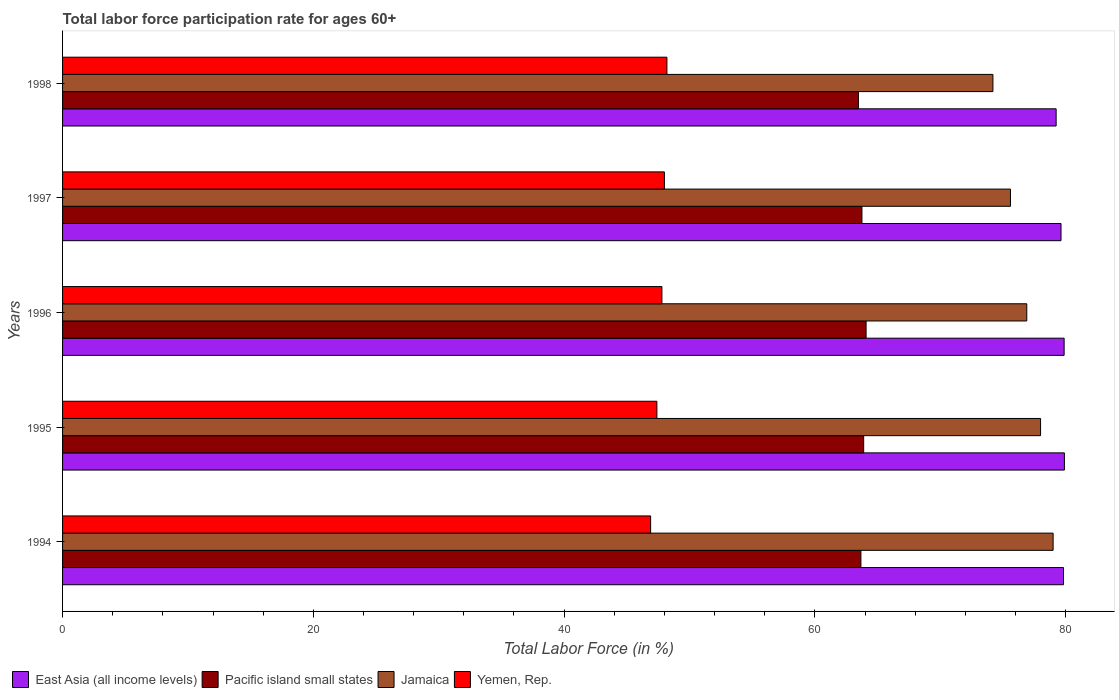How many different coloured bars are there?
Make the answer very short. 4. Are the number of bars per tick equal to the number of legend labels?
Give a very brief answer. Yes. How many bars are there on the 1st tick from the bottom?
Your answer should be compact. 4. What is the label of the 3rd group of bars from the top?
Your answer should be very brief. 1996. In how many cases, is the number of bars for a given year not equal to the number of legend labels?
Provide a short and direct response. 0. What is the labor force participation rate in Jamaica in 1997?
Offer a very short reply. 75.6. Across all years, what is the maximum labor force participation rate in East Asia (all income levels)?
Give a very brief answer. 79.9. Across all years, what is the minimum labor force participation rate in East Asia (all income levels)?
Ensure brevity in your answer.  79.24. What is the total labor force participation rate in East Asia (all income levels) in the graph?
Your response must be concise. 398.48. What is the difference between the labor force participation rate in Jamaica in 1995 and that in 1996?
Give a very brief answer. 1.1. What is the difference between the labor force participation rate in Jamaica in 1998 and the labor force participation rate in East Asia (all income levels) in 1997?
Offer a very short reply. -5.43. What is the average labor force participation rate in Jamaica per year?
Offer a very short reply. 76.74. In the year 1994, what is the difference between the labor force participation rate in East Asia (all income levels) and labor force participation rate in Pacific island small states?
Offer a very short reply. 16.16. In how many years, is the labor force participation rate in Jamaica greater than 64 %?
Your answer should be compact. 5. What is the ratio of the labor force participation rate in Pacific island small states in 1994 to that in 1997?
Give a very brief answer. 1. Is the difference between the labor force participation rate in East Asia (all income levels) in 1994 and 1996 greater than the difference between the labor force participation rate in Pacific island small states in 1994 and 1996?
Offer a very short reply. Yes. What is the difference between the highest and the second highest labor force participation rate in Yemen, Rep.?
Your answer should be compact. 0.2. What is the difference between the highest and the lowest labor force participation rate in Jamaica?
Ensure brevity in your answer.  4.8. Is it the case that in every year, the sum of the labor force participation rate in Yemen, Rep. and labor force participation rate in East Asia (all income levels) is greater than the sum of labor force participation rate in Jamaica and labor force participation rate in Pacific island small states?
Keep it short and to the point. No. What does the 3rd bar from the top in 1996 represents?
Provide a short and direct response. Pacific island small states. What does the 1st bar from the bottom in 1998 represents?
Your answer should be compact. East Asia (all income levels). How many years are there in the graph?
Your answer should be very brief. 5. What is the difference between two consecutive major ticks on the X-axis?
Give a very brief answer. 20. Are the values on the major ticks of X-axis written in scientific E-notation?
Keep it short and to the point. No. Does the graph contain grids?
Your response must be concise. No. Where does the legend appear in the graph?
Your answer should be very brief. Bottom left. What is the title of the graph?
Your answer should be very brief. Total labor force participation rate for ages 60+. Does "Caribbean small states" appear as one of the legend labels in the graph?
Your response must be concise. No. What is the label or title of the X-axis?
Offer a very short reply. Total Labor Force (in %). What is the label or title of the Y-axis?
Keep it short and to the point. Years. What is the Total Labor Force (in %) in East Asia (all income levels) in 1994?
Your response must be concise. 79.83. What is the Total Labor Force (in %) in Pacific island small states in 1994?
Ensure brevity in your answer.  63.67. What is the Total Labor Force (in %) of Jamaica in 1994?
Offer a very short reply. 79. What is the Total Labor Force (in %) in Yemen, Rep. in 1994?
Keep it short and to the point. 46.9. What is the Total Labor Force (in %) in East Asia (all income levels) in 1995?
Keep it short and to the point. 79.9. What is the Total Labor Force (in %) of Pacific island small states in 1995?
Ensure brevity in your answer.  63.89. What is the Total Labor Force (in %) in Yemen, Rep. in 1995?
Provide a succinct answer. 47.4. What is the Total Labor Force (in %) of East Asia (all income levels) in 1996?
Offer a terse response. 79.88. What is the Total Labor Force (in %) of Pacific island small states in 1996?
Make the answer very short. 64.08. What is the Total Labor Force (in %) in Jamaica in 1996?
Your answer should be compact. 76.9. What is the Total Labor Force (in %) in Yemen, Rep. in 1996?
Your response must be concise. 47.8. What is the Total Labor Force (in %) of East Asia (all income levels) in 1997?
Make the answer very short. 79.63. What is the Total Labor Force (in %) in Pacific island small states in 1997?
Offer a terse response. 63.75. What is the Total Labor Force (in %) in Jamaica in 1997?
Make the answer very short. 75.6. What is the Total Labor Force (in %) of Yemen, Rep. in 1997?
Provide a succinct answer. 48. What is the Total Labor Force (in %) of East Asia (all income levels) in 1998?
Give a very brief answer. 79.24. What is the Total Labor Force (in %) in Pacific island small states in 1998?
Provide a succinct answer. 63.47. What is the Total Labor Force (in %) of Jamaica in 1998?
Your answer should be compact. 74.2. What is the Total Labor Force (in %) of Yemen, Rep. in 1998?
Make the answer very short. 48.2. Across all years, what is the maximum Total Labor Force (in %) in East Asia (all income levels)?
Keep it short and to the point. 79.9. Across all years, what is the maximum Total Labor Force (in %) in Pacific island small states?
Provide a succinct answer. 64.08. Across all years, what is the maximum Total Labor Force (in %) of Jamaica?
Your answer should be very brief. 79. Across all years, what is the maximum Total Labor Force (in %) in Yemen, Rep.?
Keep it short and to the point. 48.2. Across all years, what is the minimum Total Labor Force (in %) in East Asia (all income levels)?
Your answer should be compact. 79.24. Across all years, what is the minimum Total Labor Force (in %) of Pacific island small states?
Provide a short and direct response. 63.47. Across all years, what is the minimum Total Labor Force (in %) in Jamaica?
Your answer should be very brief. 74.2. Across all years, what is the minimum Total Labor Force (in %) of Yemen, Rep.?
Offer a terse response. 46.9. What is the total Total Labor Force (in %) in East Asia (all income levels) in the graph?
Keep it short and to the point. 398.48. What is the total Total Labor Force (in %) of Pacific island small states in the graph?
Your response must be concise. 318.87. What is the total Total Labor Force (in %) in Jamaica in the graph?
Your answer should be compact. 383.7. What is the total Total Labor Force (in %) in Yemen, Rep. in the graph?
Your answer should be compact. 238.3. What is the difference between the Total Labor Force (in %) of East Asia (all income levels) in 1994 and that in 1995?
Ensure brevity in your answer.  -0.07. What is the difference between the Total Labor Force (in %) in Pacific island small states in 1994 and that in 1995?
Your answer should be very brief. -0.22. What is the difference between the Total Labor Force (in %) of Jamaica in 1994 and that in 1995?
Keep it short and to the point. 1. What is the difference between the Total Labor Force (in %) of East Asia (all income levels) in 1994 and that in 1996?
Ensure brevity in your answer.  -0.05. What is the difference between the Total Labor Force (in %) in Pacific island small states in 1994 and that in 1996?
Your answer should be compact. -0.41. What is the difference between the Total Labor Force (in %) in Jamaica in 1994 and that in 1996?
Your response must be concise. 2.1. What is the difference between the Total Labor Force (in %) of Yemen, Rep. in 1994 and that in 1996?
Your answer should be very brief. -0.9. What is the difference between the Total Labor Force (in %) of East Asia (all income levels) in 1994 and that in 1997?
Give a very brief answer. 0.2. What is the difference between the Total Labor Force (in %) in Pacific island small states in 1994 and that in 1997?
Offer a very short reply. -0.08. What is the difference between the Total Labor Force (in %) in East Asia (all income levels) in 1994 and that in 1998?
Keep it short and to the point. 0.59. What is the difference between the Total Labor Force (in %) of Pacific island small states in 1994 and that in 1998?
Make the answer very short. 0.2. What is the difference between the Total Labor Force (in %) of Jamaica in 1994 and that in 1998?
Your answer should be compact. 4.8. What is the difference between the Total Labor Force (in %) of East Asia (all income levels) in 1995 and that in 1996?
Your response must be concise. 0.02. What is the difference between the Total Labor Force (in %) in Pacific island small states in 1995 and that in 1996?
Your response must be concise. -0.19. What is the difference between the Total Labor Force (in %) in Jamaica in 1995 and that in 1996?
Give a very brief answer. 1.1. What is the difference between the Total Labor Force (in %) of Yemen, Rep. in 1995 and that in 1996?
Your answer should be very brief. -0.4. What is the difference between the Total Labor Force (in %) in East Asia (all income levels) in 1995 and that in 1997?
Your answer should be very brief. 0.27. What is the difference between the Total Labor Force (in %) of Pacific island small states in 1995 and that in 1997?
Give a very brief answer. 0.14. What is the difference between the Total Labor Force (in %) in Jamaica in 1995 and that in 1997?
Your answer should be very brief. 2.4. What is the difference between the Total Labor Force (in %) in Yemen, Rep. in 1995 and that in 1997?
Make the answer very short. -0.6. What is the difference between the Total Labor Force (in %) of East Asia (all income levels) in 1995 and that in 1998?
Your response must be concise. 0.66. What is the difference between the Total Labor Force (in %) of Pacific island small states in 1995 and that in 1998?
Offer a very short reply. 0.42. What is the difference between the Total Labor Force (in %) of Jamaica in 1995 and that in 1998?
Keep it short and to the point. 3.8. What is the difference between the Total Labor Force (in %) of East Asia (all income levels) in 1996 and that in 1997?
Keep it short and to the point. 0.25. What is the difference between the Total Labor Force (in %) in Pacific island small states in 1996 and that in 1997?
Give a very brief answer. 0.33. What is the difference between the Total Labor Force (in %) of Jamaica in 1996 and that in 1997?
Your answer should be compact. 1.3. What is the difference between the Total Labor Force (in %) of East Asia (all income levels) in 1996 and that in 1998?
Your answer should be very brief. 0.64. What is the difference between the Total Labor Force (in %) of Pacific island small states in 1996 and that in 1998?
Your answer should be very brief. 0.61. What is the difference between the Total Labor Force (in %) in East Asia (all income levels) in 1997 and that in 1998?
Give a very brief answer. 0.39. What is the difference between the Total Labor Force (in %) of Pacific island small states in 1997 and that in 1998?
Your answer should be compact. 0.28. What is the difference between the Total Labor Force (in %) of East Asia (all income levels) in 1994 and the Total Labor Force (in %) of Pacific island small states in 1995?
Offer a very short reply. 15.94. What is the difference between the Total Labor Force (in %) of East Asia (all income levels) in 1994 and the Total Labor Force (in %) of Jamaica in 1995?
Provide a succinct answer. 1.83. What is the difference between the Total Labor Force (in %) of East Asia (all income levels) in 1994 and the Total Labor Force (in %) of Yemen, Rep. in 1995?
Your answer should be very brief. 32.43. What is the difference between the Total Labor Force (in %) in Pacific island small states in 1994 and the Total Labor Force (in %) in Jamaica in 1995?
Ensure brevity in your answer.  -14.33. What is the difference between the Total Labor Force (in %) of Pacific island small states in 1994 and the Total Labor Force (in %) of Yemen, Rep. in 1995?
Your response must be concise. 16.27. What is the difference between the Total Labor Force (in %) of Jamaica in 1994 and the Total Labor Force (in %) of Yemen, Rep. in 1995?
Give a very brief answer. 31.6. What is the difference between the Total Labor Force (in %) of East Asia (all income levels) in 1994 and the Total Labor Force (in %) of Pacific island small states in 1996?
Your answer should be compact. 15.74. What is the difference between the Total Labor Force (in %) in East Asia (all income levels) in 1994 and the Total Labor Force (in %) in Jamaica in 1996?
Make the answer very short. 2.93. What is the difference between the Total Labor Force (in %) in East Asia (all income levels) in 1994 and the Total Labor Force (in %) in Yemen, Rep. in 1996?
Offer a very short reply. 32.03. What is the difference between the Total Labor Force (in %) of Pacific island small states in 1994 and the Total Labor Force (in %) of Jamaica in 1996?
Provide a succinct answer. -13.23. What is the difference between the Total Labor Force (in %) in Pacific island small states in 1994 and the Total Labor Force (in %) in Yemen, Rep. in 1996?
Provide a short and direct response. 15.87. What is the difference between the Total Labor Force (in %) of Jamaica in 1994 and the Total Labor Force (in %) of Yemen, Rep. in 1996?
Keep it short and to the point. 31.2. What is the difference between the Total Labor Force (in %) of East Asia (all income levels) in 1994 and the Total Labor Force (in %) of Pacific island small states in 1997?
Your answer should be very brief. 16.07. What is the difference between the Total Labor Force (in %) of East Asia (all income levels) in 1994 and the Total Labor Force (in %) of Jamaica in 1997?
Give a very brief answer. 4.23. What is the difference between the Total Labor Force (in %) of East Asia (all income levels) in 1994 and the Total Labor Force (in %) of Yemen, Rep. in 1997?
Keep it short and to the point. 31.83. What is the difference between the Total Labor Force (in %) in Pacific island small states in 1994 and the Total Labor Force (in %) in Jamaica in 1997?
Make the answer very short. -11.93. What is the difference between the Total Labor Force (in %) of Pacific island small states in 1994 and the Total Labor Force (in %) of Yemen, Rep. in 1997?
Make the answer very short. 15.67. What is the difference between the Total Labor Force (in %) of East Asia (all income levels) in 1994 and the Total Labor Force (in %) of Pacific island small states in 1998?
Provide a short and direct response. 16.36. What is the difference between the Total Labor Force (in %) of East Asia (all income levels) in 1994 and the Total Labor Force (in %) of Jamaica in 1998?
Your response must be concise. 5.63. What is the difference between the Total Labor Force (in %) of East Asia (all income levels) in 1994 and the Total Labor Force (in %) of Yemen, Rep. in 1998?
Ensure brevity in your answer.  31.63. What is the difference between the Total Labor Force (in %) in Pacific island small states in 1994 and the Total Labor Force (in %) in Jamaica in 1998?
Offer a very short reply. -10.53. What is the difference between the Total Labor Force (in %) of Pacific island small states in 1994 and the Total Labor Force (in %) of Yemen, Rep. in 1998?
Your answer should be very brief. 15.47. What is the difference between the Total Labor Force (in %) in Jamaica in 1994 and the Total Labor Force (in %) in Yemen, Rep. in 1998?
Provide a succinct answer. 30.8. What is the difference between the Total Labor Force (in %) of East Asia (all income levels) in 1995 and the Total Labor Force (in %) of Pacific island small states in 1996?
Provide a short and direct response. 15.82. What is the difference between the Total Labor Force (in %) of East Asia (all income levels) in 1995 and the Total Labor Force (in %) of Jamaica in 1996?
Provide a succinct answer. 3. What is the difference between the Total Labor Force (in %) in East Asia (all income levels) in 1995 and the Total Labor Force (in %) in Yemen, Rep. in 1996?
Provide a succinct answer. 32.1. What is the difference between the Total Labor Force (in %) of Pacific island small states in 1995 and the Total Labor Force (in %) of Jamaica in 1996?
Your response must be concise. -13.01. What is the difference between the Total Labor Force (in %) in Pacific island small states in 1995 and the Total Labor Force (in %) in Yemen, Rep. in 1996?
Your response must be concise. 16.09. What is the difference between the Total Labor Force (in %) in Jamaica in 1995 and the Total Labor Force (in %) in Yemen, Rep. in 1996?
Your answer should be compact. 30.2. What is the difference between the Total Labor Force (in %) of East Asia (all income levels) in 1995 and the Total Labor Force (in %) of Pacific island small states in 1997?
Give a very brief answer. 16.15. What is the difference between the Total Labor Force (in %) of East Asia (all income levels) in 1995 and the Total Labor Force (in %) of Jamaica in 1997?
Make the answer very short. 4.3. What is the difference between the Total Labor Force (in %) in East Asia (all income levels) in 1995 and the Total Labor Force (in %) in Yemen, Rep. in 1997?
Your answer should be compact. 31.9. What is the difference between the Total Labor Force (in %) of Pacific island small states in 1995 and the Total Labor Force (in %) of Jamaica in 1997?
Provide a succinct answer. -11.71. What is the difference between the Total Labor Force (in %) of Pacific island small states in 1995 and the Total Labor Force (in %) of Yemen, Rep. in 1997?
Your answer should be compact. 15.89. What is the difference between the Total Labor Force (in %) in Jamaica in 1995 and the Total Labor Force (in %) in Yemen, Rep. in 1997?
Give a very brief answer. 30. What is the difference between the Total Labor Force (in %) of East Asia (all income levels) in 1995 and the Total Labor Force (in %) of Pacific island small states in 1998?
Offer a very short reply. 16.43. What is the difference between the Total Labor Force (in %) of East Asia (all income levels) in 1995 and the Total Labor Force (in %) of Jamaica in 1998?
Your answer should be compact. 5.7. What is the difference between the Total Labor Force (in %) of East Asia (all income levels) in 1995 and the Total Labor Force (in %) of Yemen, Rep. in 1998?
Provide a short and direct response. 31.7. What is the difference between the Total Labor Force (in %) in Pacific island small states in 1995 and the Total Labor Force (in %) in Jamaica in 1998?
Your response must be concise. -10.31. What is the difference between the Total Labor Force (in %) in Pacific island small states in 1995 and the Total Labor Force (in %) in Yemen, Rep. in 1998?
Ensure brevity in your answer.  15.69. What is the difference between the Total Labor Force (in %) in Jamaica in 1995 and the Total Labor Force (in %) in Yemen, Rep. in 1998?
Your answer should be compact. 29.8. What is the difference between the Total Labor Force (in %) in East Asia (all income levels) in 1996 and the Total Labor Force (in %) in Pacific island small states in 1997?
Offer a terse response. 16.13. What is the difference between the Total Labor Force (in %) of East Asia (all income levels) in 1996 and the Total Labor Force (in %) of Jamaica in 1997?
Give a very brief answer. 4.28. What is the difference between the Total Labor Force (in %) in East Asia (all income levels) in 1996 and the Total Labor Force (in %) in Yemen, Rep. in 1997?
Your answer should be very brief. 31.88. What is the difference between the Total Labor Force (in %) in Pacific island small states in 1996 and the Total Labor Force (in %) in Jamaica in 1997?
Keep it short and to the point. -11.52. What is the difference between the Total Labor Force (in %) in Pacific island small states in 1996 and the Total Labor Force (in %) in Yemen, Rep. in 1997?
Make the answer very short. 16.08. What is the difference between the Total Labor Force (in %) in Jamaica in 1996 and the Total Labor Force (in %) in Yemen, Rep. in 1997?
Your answer should be compact. 28.9. What is the difference between the Total Labor Force (in %) in East Asia (all income levels) in 1996 and the Total Labor Force (in %) in Pacific island small states in 1998?
Offer a very short reply. 16.41. What is the difference between the Total Labor Force (in %) of East Asia (all income levels) in 1996 and the Total Labor Force (in %) of Jamaica in 1998?
Your response must be concise. 5.68. What is the difference between the Total Labor Force (in %) of East Asia (all income levels) in 1996 and the Total Labor Force (in %) of Yemen, Rep. in 1998?
Provide a short and direct response. 31.68. What is the difference between the Total Labor Force (in %) of Pacific island small states in 1996 and the Total Labor Force (in %) of Jamaica in 1998?
Make the answer very short. -10.12. What is the difference between the Total Labor Force (in %) of Pacific island small states in 1996 and the Total Labor Force (in %) of Yemen, Rep. in 1998?
Your answer should be compact. 15.88. What is the difference between the Total Labor Force (in %) of Jamaica in 1996 and the Total Labor Force (in %) of Yemen, Rep. in 1998?
Give a very brief answer. 28.7. What is the difference between the Total Labor Force (in %) of East Asia (all income levels) in 1997 and the Total Labor Force (in %) of Pacific island small states in 1998?
Your answer should be very brief. 16.16. What is the difference between the Total Labor Force (in %) of East Asia (all income levels) in 1997 and the Total Labor Force (in %) of Jamaica in 1998?
Provide a succinct answer. 5.43. What is the difference between the Total Labor Force (in %) of East Asia (all income levels) in 1997 and the Total Labor Force (in %) of Yemen, Rep. in 1998?
Give a very brief answer. 31.43. What is the difference between the Total Labor Force (in %) in Pacific island small states in 1997 and the Total Labor Force (in %) in Jamaica in 1998?
Provide a short and direct response. -10.45. What is the difference between the Total Labor Force (in %) in Pacific island small states in 1997 and the Total Labor Force (in %) in Yemen, Rep. in 1998?
Ensure brevity in your answer.  15.55. What is the difference between the Total Labor Force (in %) in Jamaica in 1997 and the Total Labor Force (in %) in Yemen, Rep. in 1998?
Keep it short and to the point. 27.4. What is the average Total Labor Force (in %) of East Asia (all income levels) per year?
Keep it short and to the point. 79.7. What is the average Total Labor Force (in %) in Pacific island small states per year?
Your answer should be compact. 63.77. What is the average Total Labor Force (in %) of Jamaica per year?
Your answer should be compact. 76.74. What is the average Total Labor Force (in %) of Yemen, Rep. per year?
Your response must be concise. 47.66. In the year 1994, what is the difference between the Total Labor Force (in %) of East Asia (all income levels) and Total Labor Force (in %) of Pacific island small states?
Provide a succinct answer. 16.16. In the year 1994, what is the difference between the Total Labor Force (in %) of East Asia (all income levels) and Total Labor Force (in %) of Jamaica?
Provide a short and direct response. 0.83. In the year 1994, what is the difference between the Total Labor Force (in %) of East Asia (all income levels) and Total Labor Force (in %) of Yemen, Rep.?
Ensure brevity in your answer.  32.93. In the year 1994, what is the difference between the Total Labor Force (in %) in Pacific island small states and Total Labor Force (in %) in Jamaica?
Keep it short and to the point. -15.33. In the year 1994, what is the difference between the Total Labor Force (in %) in Pacific island small states and Total Labor Force (in %) in Yemen, Rep.?
Your answer should be very brief. 16.77. In the year 1994, what is the difference between the Total Labor Force (in %) of Jamaica and Total Labor Force (in %) of Yemen, Rep.?
Make the answer very short. 32.1. In the year 1995, what is the difference between the Total Labor Force (in %) in East Asia (all income levels) and Total Labor Force (in %) in Pacific island small states?
Provide a succinct answer. 16.01. In the year 1995, what is the difference between the Total Labor Force (in %) in East Asia (all income levels) and Total Labor Force (in %) in Jamaica?
Your response must be concise. 1.9. In the year 1995, what is the difference between the Total Labor Force (in %) of East Asia (all income levels) and Total Labor Force (in %) of Yemen, Rep.?
Make the answer very short. 32.5. In the year 1995, what is the difference between the Total Labor Force (in %) in Pacific island small states and Total Labor Force (in %) in Jamaica?
Offer a terse response. -14.11. In the year 1995, what is the difference between the Total Labor Force (in %) in Pacific island small states and Total Labor Force (in %) in Yemen, Rep.?
Make the answer very short. 16.49. In the year 1995, what is the difference between the Total Labor Force (in %) in Jamaica and Total Labor Force (in %) in Yemen, Rep.?
Offer a terse response. 30.6. In the year 1996, what is the difference between the Total Labor Force (in %) of East Asia (all income levels) and Total Labor Force (in %) of Pacific island small states?
Give a very brief answer. 15.79. In the year 1996, what is the difference between the Total Labor Force (in %) of East Asia (all income levels) and Total Labor Force (in %) of Jamaica?
Offer a very short reply. 2.98. In the year 1996, what is the difference between the Total Labor Force (in %) in East Asia (all income levels) and Total Labor Force (in %) in Yemen, Rep.?
Ensure brevity in your answer.  32.08. In the year 1996, what is the difference between the Total Labor Force (in %) in Pacific island small states and Total Labor Force (in %) in Jamaica?
Give a very brief answer. -12.82. In the year 1996, what is the difference between the Total Labor Force (in %) of Pacific island small states and Total Labor Force (in %) of Yemen, Rep.?
Offer a terse response. 16.28. In the year 1996, what is the difference between the Total Labor Force (in %) of Jamaica and Total Labor Force (in %) of Yemen, Rep.?
Ensure brevity in your answer.  29.1. In the year 1997, what is the difference between the Total Labor Force (in %) in East Asia (all income levels) and Total Labor Force (in %) in Pacific island small states?
Your answer should be very brief. 15.88. In the year 1997, what is the difference between the Total Labor Force (in %) of East Asia (all income levels) and Total Labor Force (in %) of Jamaica?
Offer a terse response. 4.03. In the year 1997, what is the difference between the Total Labor Force (in %) in East Asia (all income levels) and Total Labor Force (in %) in Yemen, Rep.?
Your answer should be very brief. 31.63. In the year 1997, what is the difference between the Total Labor Force (in %) of Pacific island small states and Total Labor Force (in %) of Jamaica?
Provide a short and direct response. -11.85. In the year 1997, what is the difference between the Total Labor Force (in %) in Pacific island small states and Total Labor Force (in %) in Yemen, Rep.?
Keep it short and to the point. 15.75. In the year 1997, what is the difference between the Total Labor Force (in %) in Jamaica and Total Labor Force (in %) in Yemen, Rep.?
Offer a very short reply. 27.6. In the year 1998, what is the difference between the Total Labor Force (in %) of East Asia (all income levels) and Total Labor Force (in %) of Pacific island small states?
Provide a short and direct response. 15.77. In the year 1998, what is the difference between the Total Labor Force (in %) in East Asia (all income levels) and Total Labor Force (in %) in Jamaica?
Keep it short and to the point. 5.04. In the year 1998, what is the difference between the Total Labor Force (in %) in East Asia (all income levels) and Total Labor Force (in %) in Yemen, Rep.?
Provide a short and direct response. 31.04. In the year 1998, what is the difference between the Total Labor Force (in %) in Pacific island small states and Total Labor Force (in %) in Jamaica?
Give a very brief answer. -10.73. In the year 1998, what is the difference between the Total Labor Force (in %) in Pacific island small states and Total Labor Force (in %) in Yemen, Rep.?
Give a very brief answer. 15.27. What is the ratio of the Total Labor Force (in %) in East Asia (all income levels) in 1994 to that in 1995?
Offer a terse response. 1. What is the ratio of the Total Labor Force (in %) of Pacific island small states in 1994 to that in 1995?
Provide a short and direct response. 1. What is the ratio of the Total Labor Force (in %) of Jamaica in 1994 to that in 1995?
Offer a terse response. 1.01. What is the ratio of the Total Labor Force (in %) in Yemen, Rep. in 1994 to that in 1995?
Provide a short and direct response. 0.99. What is the ratio of the Total Labor Force (in %) in Pacific island small states in 1994 to that in 1996?
Provide a succinct answer. 0.99. What is the ratio of the Total Labor Force (in %) in Jamaica in 1994 to that in 1996?
Keep it short and to the point. 1.03. What is the ratio of the Total Labor Force (in %) in Yemen, Rep. in 1994 to that in 1996?
Offer a terse response. 0.98. What is the ratio of the Total Labor Force (in %) of Pacific island small states in 1994 to that in 1997?
Your answer should be compact. 1. What is the ratio of the Total Labor Force (in %) in Jamaica in 1994 to that in 1997?
Ensure brevity in your answer.  1.04. What is the ratio of the Total Labor Force (in %) of Yemen, Rep. in 1994 to that in 1997?
Your answer should be compact. 0.98. What is the ratio of the Total Labor Force (in %) of East Asia (all income levels) in 1994 to that in 1998?
Ensure brevity in your answer.  1.01. What is the ratio of the Total Labor Force (in %) of Pacific island small states in 1994 to that in 1998?
Offer a very short reply. 1. What is the ratio of the Total Labor Force (in %) of Jamaica in 1994 to that in 1998?
Keep it short and to the point. 1.06. What is the ratio of the Total Labor Force (in %) of East Asia (all income levels) in 1995 to that in 1996?
Offer a terse response. 1. What is the ratio of the Total Labor Force (in %) of Pacific island small states in 1995 to that in 1996?
Your answer should be compact. 1. What is the ratio of the Total Labor Force (in %) of Jamaica in 1995 to that in 1996?
Provide a short and direct response. 1.01. What is the ratio of the Total Labor Force (in %) in Yemen, Rep. in 1995 to that in 1996?
Make the answer very short. 0.99. What is the ratio of the Total Labor Force (in %) of Pacific island small states in 1995 to that in 1997?
Keep it short and to the point. 1. What is the ratio of the Total Labor Force (in %) of Jamaica in 1995 to that in 1997?
Keep it short and to the point. 1.03. What is the ratio of the Total Labor Force (in %) of Yemen, Rep. in 1995 to that in 1997?
Your answer should be compact. 0.99. What is the ratio of the Total Labor Force (in %) of East Asia (all income levels) in 1995 to that in 1998?
Provide a succinct answer. 1.01. What is the ratio of the Total Labor Force (in %) in Pacific island small states in 1995 to that in 1998?
Your answer should be very brief. 1.01. What is the ratio of the Total Labor Force (in %) in Jamaica in 1995 to that in 1998?
Your answer should be very brief. 1.05. What is the ratio of the Total Labor Force (in %) in Yemen, Rep. in 1995 to that in 1998?
Keep it short and to the point. 0.98. What is the ratio of the Total Labor Force (in %) of East Asia (all income levels) in 1996 to that in 1997?
Your answer should be very brief. 1. What is the ratio of the Total Labor Force (in %) in Jamaica in 1996 to that in 1997?
Provide a short and direct response. 1.02. What is the ratio of the Total Labor Force (in %) of East Asia (all income levels) in 1996 to that in 1998?
Make the answer very short. 1.01. What is the ratio of the Total Labor Force (in %) in Pacific island small states in 1996 to that in 1998?
Your answer should be very brief. 1.01. What is the ratio of the Total Labor Force (in %) of Jamaica in 1996 to that in 1998?
Offer a terse response. 1.04. What is the ratio of the Total Labor Force (in %) of East Asia (all income levels) in 1997 to that in 1998?
Offer a very short reply. 1. What is the ratio of the Total Labor Force (in %) in Jamaica in 1997 to that in 1998?
Ensure brevity in your answer.  1.02. What is the ratio of the Total Labor Force (in %) of Yemen, Rep. in 1997 to that in 1998?
Offer a terse response. 1. What is the difference between the highest and the second highest Total Labor Force (in %) of East Asia (all income levels)?
Ensure brevity in your answer.  0.02. What is the difference between the highest and the second highest Total Labor Force (in %) in Pacific island small states?
Provide a short and direct response. 0.19. What is the difference between the highest and the lowest Total Labor Force (in %) in East Asia (all income levels)?
Provide a succinct answer. 0.66. What is the difference between the highest and the lowest Total Labor Force (in %) in Pacific island small states?
Keep it short and to the point. 0.61. What is the difference between the highest and the lowest Total Labor Force (in %) in Jamaica?
Offer a very short reply. 4.8. 